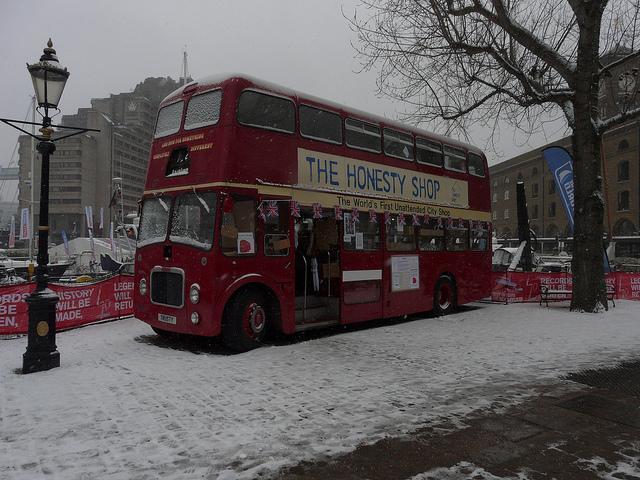Which side of the bus can people enter through?
Make your selection from the four choices given to correctly answer the question.
Options: Driver side, back side, passenger side, top side. Driver side. 